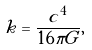Convert formula to latex. <formula><loc_0><loc_0><loc_500><loc_500>k = \frac { c ^ { 4 } } { 1 6 \pi G } ,</formula> 